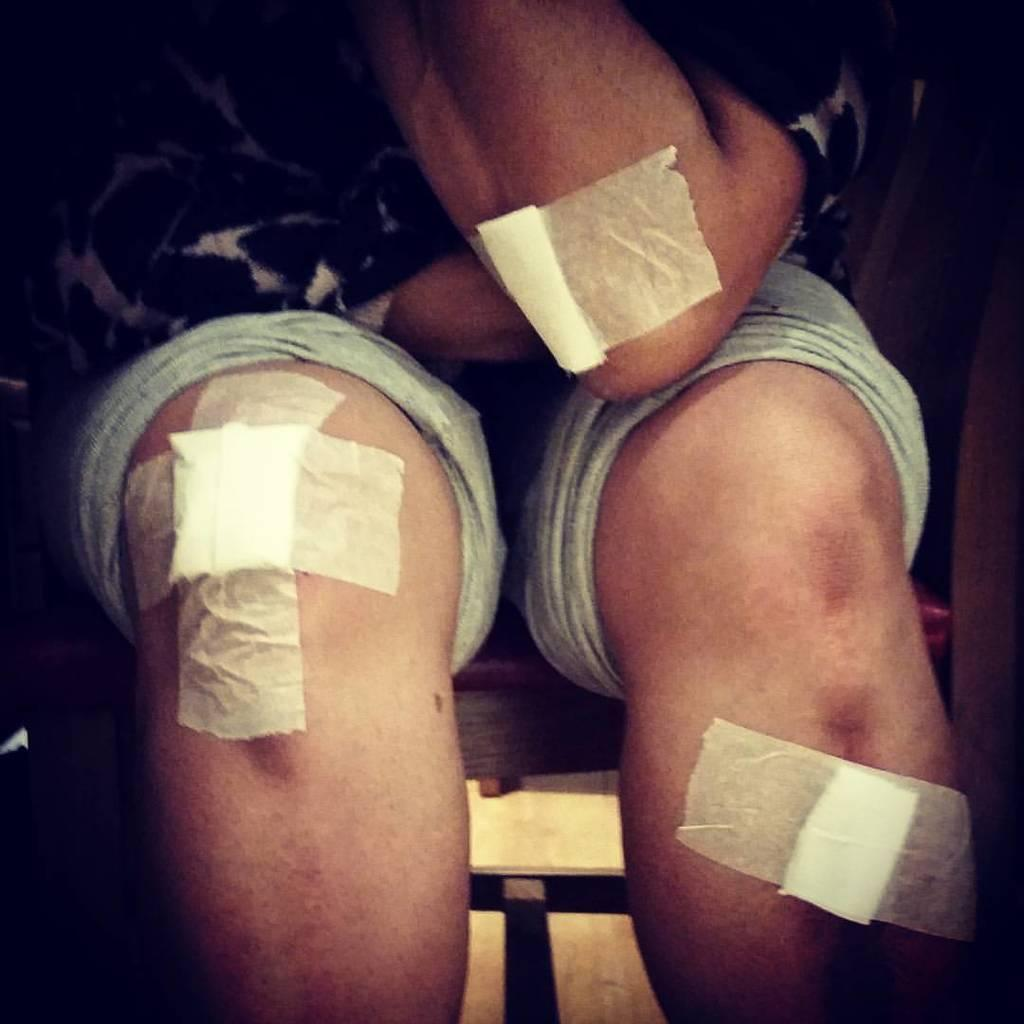What is the main subject of the image? There is a person in the image. What is the person doing in the image? The person is sitting. Can you describe the person's appearance in the image? The person has bandages on their hands and legs. What type of religion is being practiced by the person in the image? There is no indication of any religious practice in the image. Can you see a pencil in the person's hand in the image? There is no pencil visible in the person's hand in the image. 